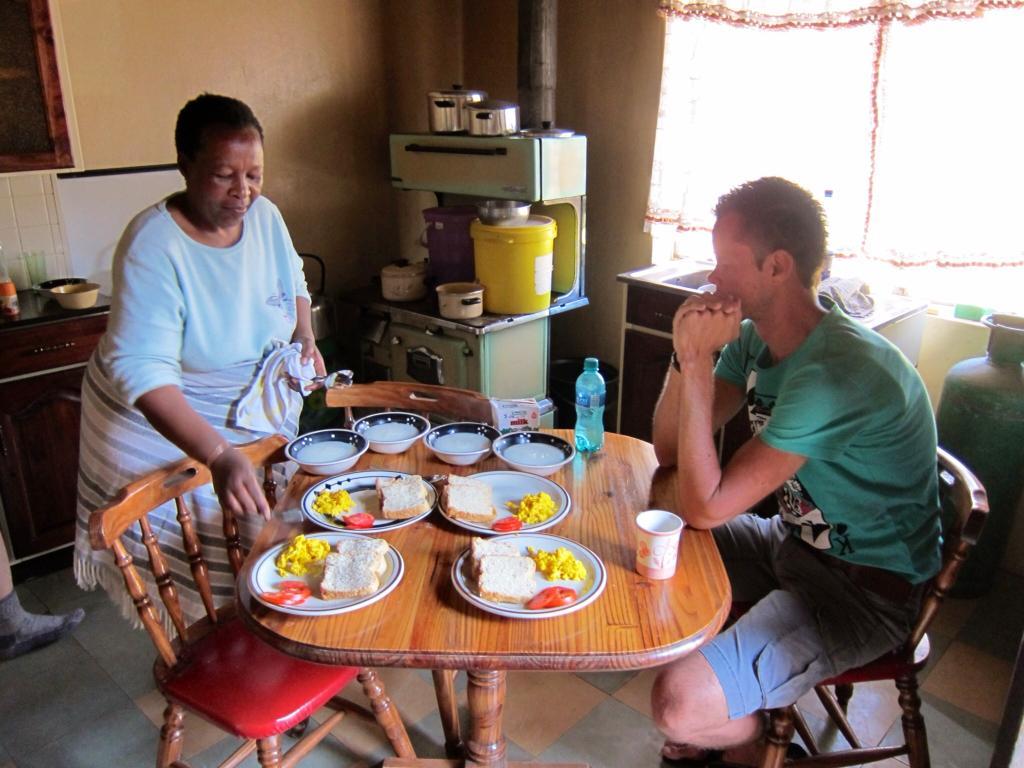Can you describe this image briefly? In this image there is a woman serving food to a person sitting on a chair in front of a dining table, on the table there are four plates with bread and other food items, beside the plates there are four bowls, a bottle of water and a mug, there are two chairs, in the background of the image there is a stove, kitchen utensils, sink, gas cylinder and a kitchen platform, on top of the kitchen platform there are a few other utensils, behind the person there is a curtain on the window. 